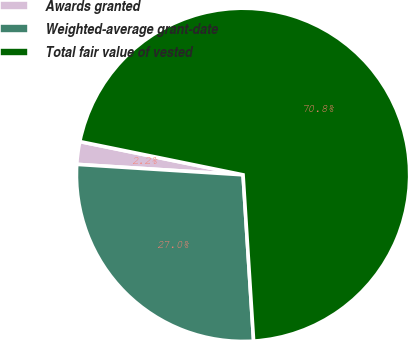Convert chart. <chart><loc_0><loc_0><loc_500><loc_500><pie_chart><fcel>Awards granted<fcel>Weighted-average grant-date<fcel>Total fair value of vested<nl><fcel>2.2%<fcel>27.01%<fcel>70.79%<nl></chart> 